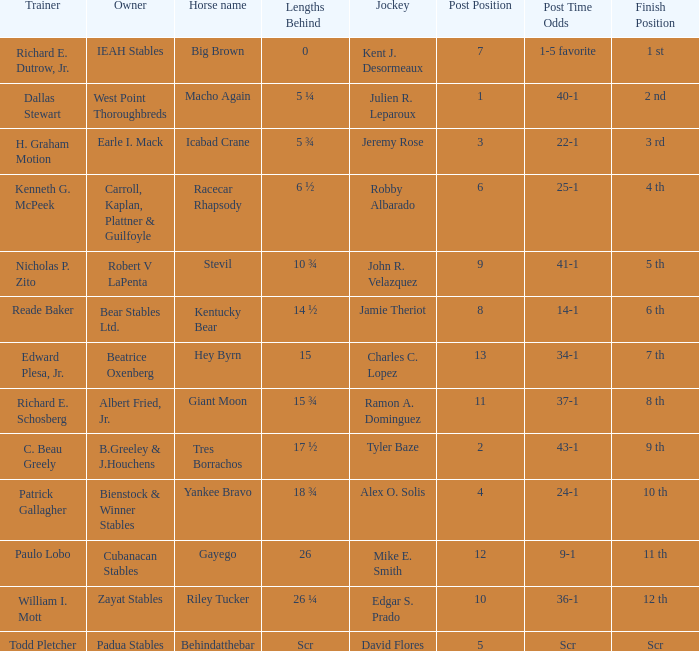Who is the owner of Icabad Crane? Earle I. Mack. Help me parse the entirety of this table. {'header': ['Trainer', 'Owner', 'Horse name', 'Lengths Behind', 'Jockey', 'Post Position', 'Post Time Odds', 'Finish Position'], 'rows': [['Richard E. Dutrow, Jr.', 'IEAH Stables', 'Big Brown', '0', 'Kent J. Desormeaux', '7', '1-5 favorite', '1 st'], ['Dallas Stewart', 'West Point Thoroughbreds', 'Macho Again', '5 ¼', 'Julien R. Leparoux', '1', '40-1', '2 nd'], ['H. Graham Motion', 'Earle I. Mack', 'Icabad Crane', '5 ¾', 'Jeremy Rose', '3', '22-1', '3 rd'], ['Kenneth G. McPeek', 'Carroll, Kaplan, Plattner & Guilfoyle', 'Racecar Rhapsody', '6 ½', 'Robby Albarado', '6', '25-1', '4 th'], ['Nicholas P. Zito', 'Robert V LaPenta', 'Stevil', '10 ¾', 'John R. Velazquez', '9', '41-1', '5 th'], ['Reade Baker', 'Bear Stables Ltd.', 'Kentucky Bear', '14 ½', 'Jamie Theriot', '8', '14-1', '6 th'], ['Edward Plesa, Jr.', 'Beatrice Oxenberg', 'Hey Byrn', '15', 'Charles C. Lopez', '13', '34-1', '7 th'], ['Richard E. Schosberg', 'Albert Fried, Jr.', 'Giant Moon', '15 ¾', 'Ramon A. Dominguez', '11', '37-1', '8 th'], ['C. Beau Greely', 'B.Greeley & J.Houchens', 'Tres Borrachos', '17 ½', 'Tyler Baze', '2', '43-1', '9 th'], ['Patrick Gallagher', 'Bienstock & Winner Stables', 'Yankee Bravo', '18 ¾', 'Alex O. Solis', '4', '24-1', '10 th'], ['Paulo Lobo', 'Cubanacan Stables', 'Gayego', '26', 'Mike E. Smith', '12', '9-1', '11 th'], ['William I. Mott', 'Zayat Stables', 'Riley Tucker', '26 ¼', 'Edgar S. Prado', '10', '36-1', '12 th'], ['Todd Pletcher', 'Padua Stables', 'Behindatthebar', 'Scr', 'David Flores', '5', 'Scr', 'Scr']]} 